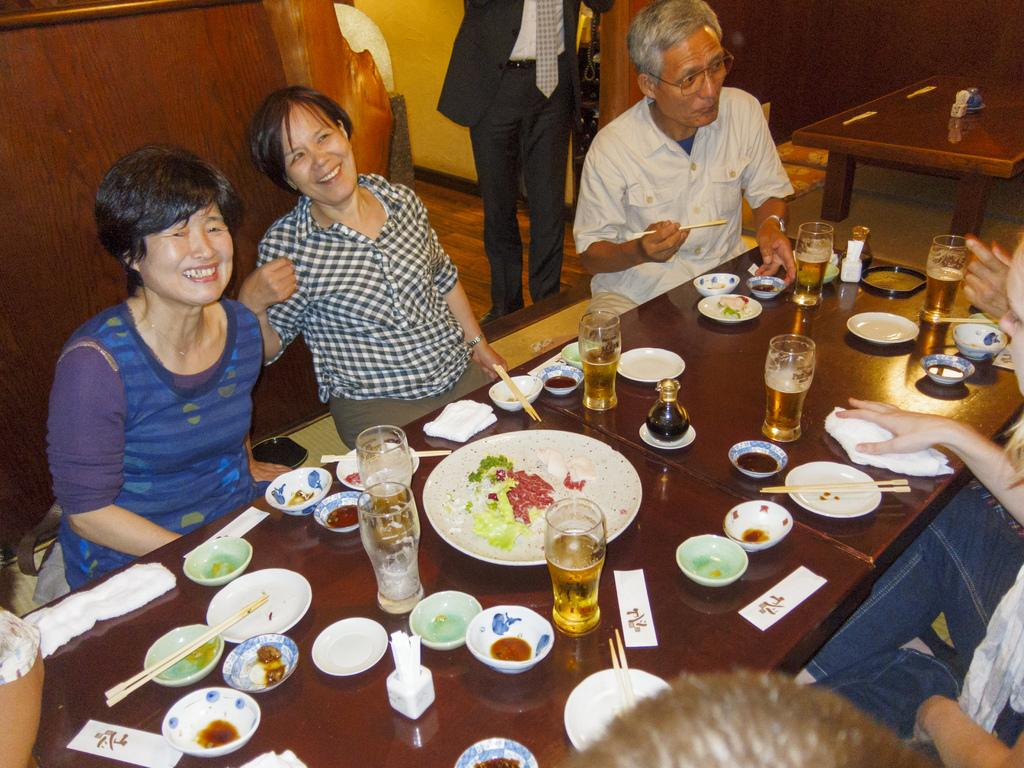How many people are in the group that is visible in the image? There is a group of people in the image, but the exact number is not specified. What are the people in the group doing? The people in the group are sitting and having their meal. What type of beverage is present on the table? There are glasses of beer on the table. What type of utensils are visible on the table? Chopsticks are visible on the table. What other items can be seen on the table? There are plates and bowls on the table. Is there anyone standing in the image? Yes, there is a man standing behind the group of people. What type of protest is taking place in the image? There is no protest present in the image; it shows a group of people having a meal. What type of school is depicted in the image? There is no school present in the image; it shows a group of people having a meal. 